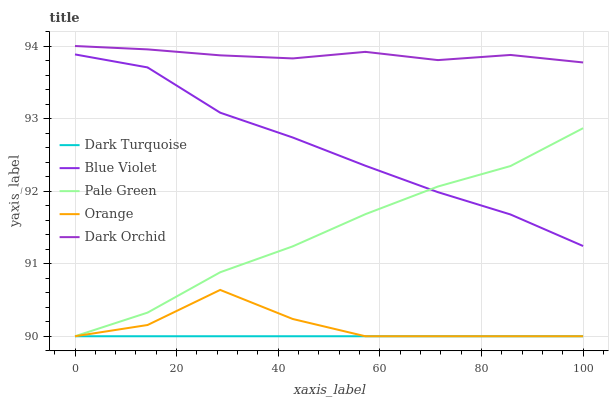Does Dark Turquoise have the minimum area under the curve?
Answer yes or no. Yes. Does Dark Orchid have the maximum area under the curve?
Answer yes or no. Yes. Does Pale Green have the minimum area under the curve?
Answer yes or no. No. Does Pale Green have the maximum area under the curve?
Answer yes or no. No. Is Dark Turquoise the smoothest?
Answer yes or no. Yes. Is Orange the roughest?
Answer yes or no. Yes. Is Pale Green the smoothest?
Answer yes or no. No. Is Pale Green the roughest?
Answer yes or no. No. Does Orange have the lowest value?
Answer yes or no. Yes. Does Dark Orchid have the lowest value?
Answer yes or no. No. Does Dark Orchid have the highest value?
Answer yes or no. Yes. Does Pale Green have the highest value?
Answer yes or no. No. Is Dark Turquoise less than Blue Violet?
Answer yes or no. Yes. Is Dark Orchid greater than Blue Violet?
Answer yes or no. Yes. Does Orange intersect Pale Green?
Answer yes or no. Yes. Is Orange less than Pale Green?
Answer yes or no. No. Is Orange greater than Pale Green?
Answer yes or no. No. Does Dark Turquoise intersect Blue Violet?
Answer yes or no. No. 